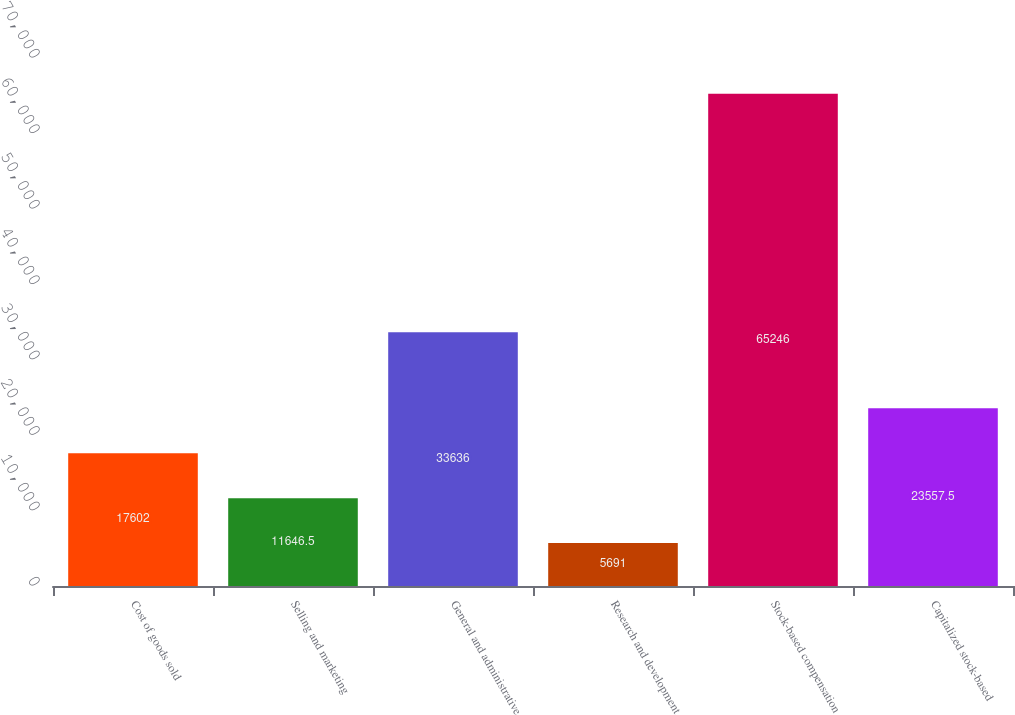Convert chart. <chart><loc_0><loc_0><loc_500><loc_500><bar_chart><fcel>Cost of goods sold<fcel>Selling and marketing<fcel>General and administrative<fcel>Research and development<fcel>Stock-based compensation<fcel>Capitalized stock-based<nl><fcel>17602<fcel>11646.5<fcel>33636<fcel>5691<fcel>65246<fcel>23557.5<nl></chart> 